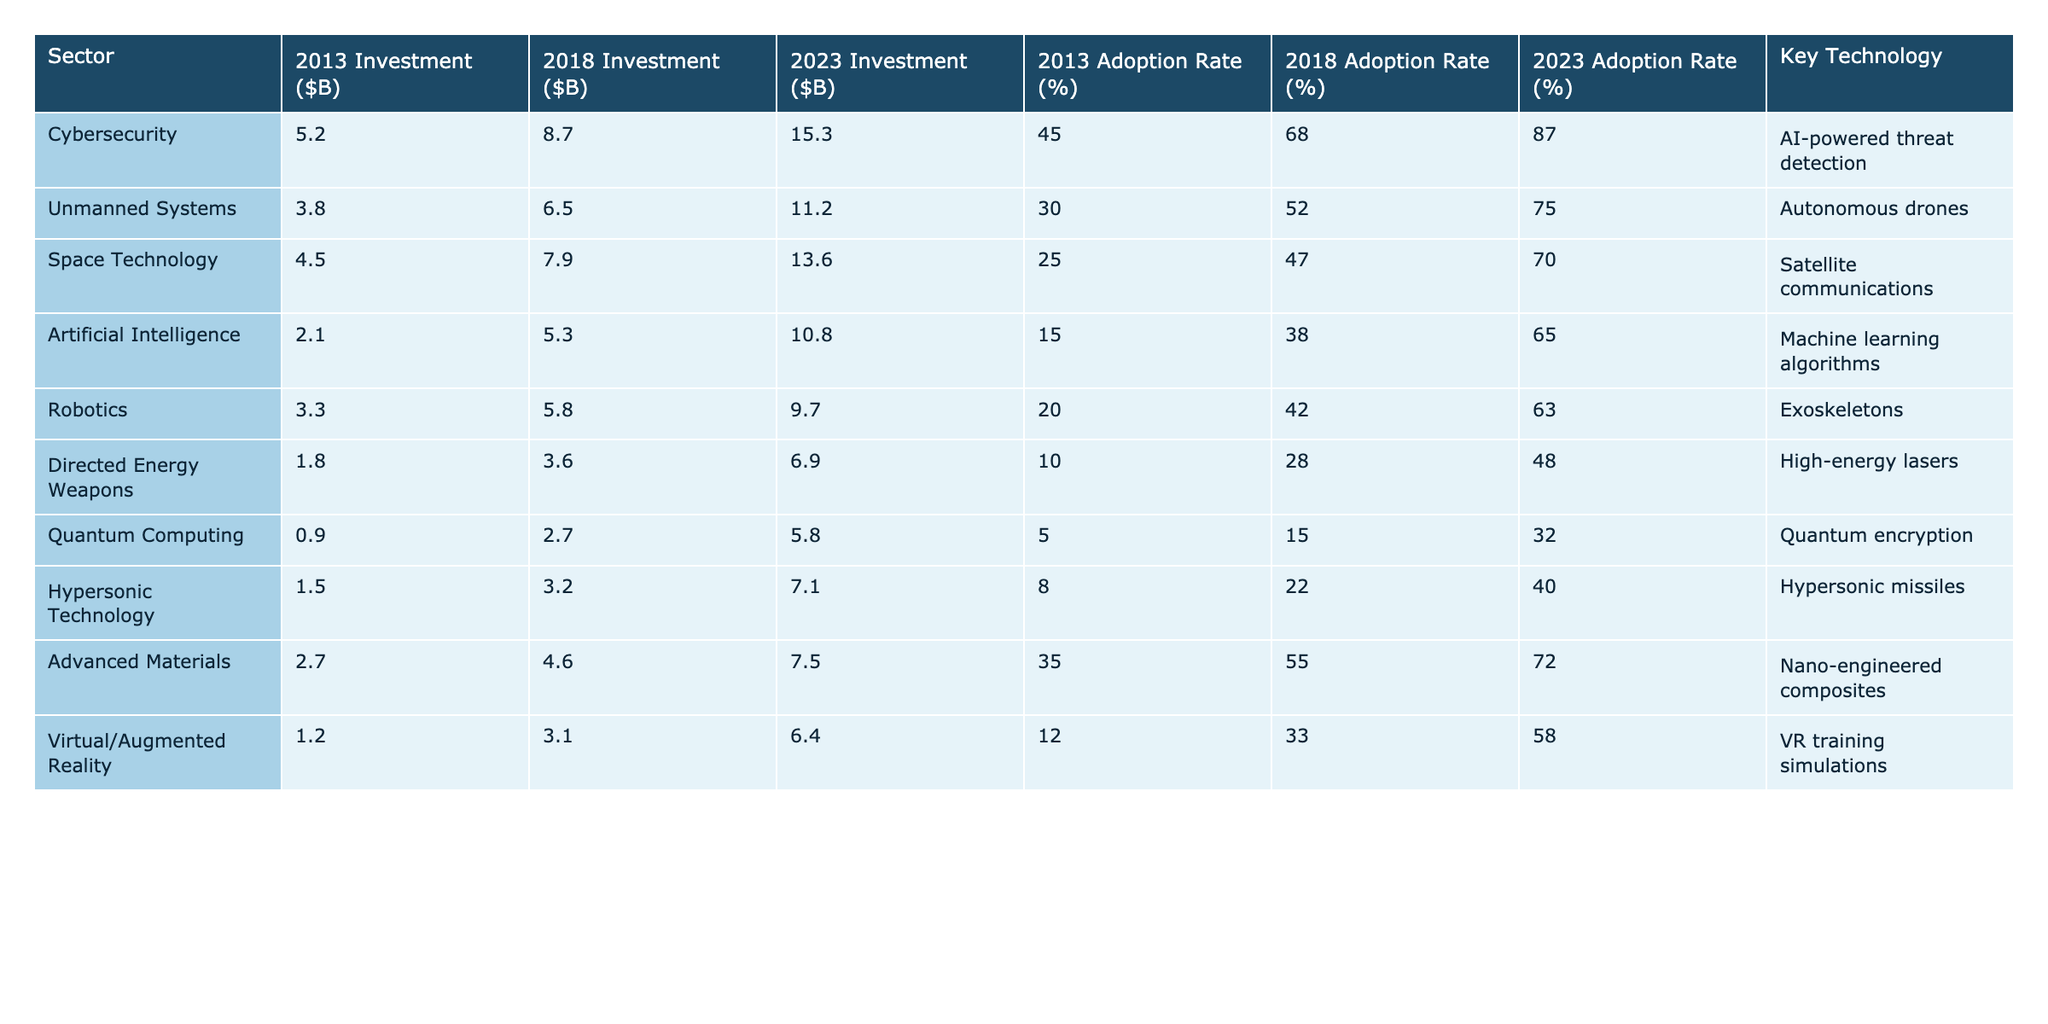What was the investment in Cybersecurity in 2018? The table shows that the investment in Cybersecurity in 2018 was $8.7 billion.
Answer: 8.7 billion Which sector had the lowest investment in 2013? Reviewing the investments in 2013, Quantum Computing had the lowest investment at $0.9 billion.
Answer: Quantum Computing What is the difference in investment for Unmanned Systems between 2023 and 2013? The investment in Unmanned Systems increased from $3.8 billion in 2013 to $11.2 billion in 2023. The difference is $11.2 billion - $3.8 billion = $7.4 billion.
Answer: 7.4 billion In which sector did the adoption rate increase the most from 2013 to 2023? Looking at the adoption rates, Cybersecurity had an increase from 45% in 2013 to 87% in 2023, which is a total increase of 42%. This is the highest increase compared to other sectors.
Answer: Cybersecurity What is the average investment across all sectors in 2023? The total investment across all sectors in 2023 is $15.3 + $11.2 + $13.6 + $10.8 + $9.7 + $6.9 + $5.8 + $7.1 + $7.5 + $6.4 = $90.5 billion. There are 10 sectors, so the average is $90.5 billion / 10 = $9.05 billion.
Answer: 9.05 billion Did the adoption rate for Quantum Computing exceed 30% in 2023? The table shows that the adoption rate for Quantum Computing in 2023 is 32%, which is greater than 30%.
Answer: Yes How much did the investment in Robotics change from 2013 to 2023 in percentage terms? The investment in Robotics increased from $3.3 billion in 2013 to $9.7 billion in 2023. The percentage change can be calculated as ((9.7 - 3.3) / 3.3) * 100 = 194.0%.
Answer: 194.0% If we compare the adoption rates for Artificial Intelligence and Space Technology in 2023, which one had a higher rate? The table states that the adoption rate for Artificial Intelligence in 2023 is 65%, while that for Space Technology is 70%. Since 70% is greater than 65%, Space Technology had a higher rate.
Answer: Space Technology Which sector saw the smallest adoption rate increase from 2013 to 2023? The sector with the smallest increase in adoption rate is Directed Energy Weapons, which went from 10% in 2013 to 48% in 2023, an increase of 38%.
Answer: Directed Energy Weapons What is the total investment in all sectors for 2013? The total investment in all sectors for 2013 is $5.2 + $3.8 + $4.5 + $2.1 + $3.3 + $1.8 + $0.9 + $1.5 + $2.7 + $1.2 = $25.0 billion.
Answer: 25.0 billion 